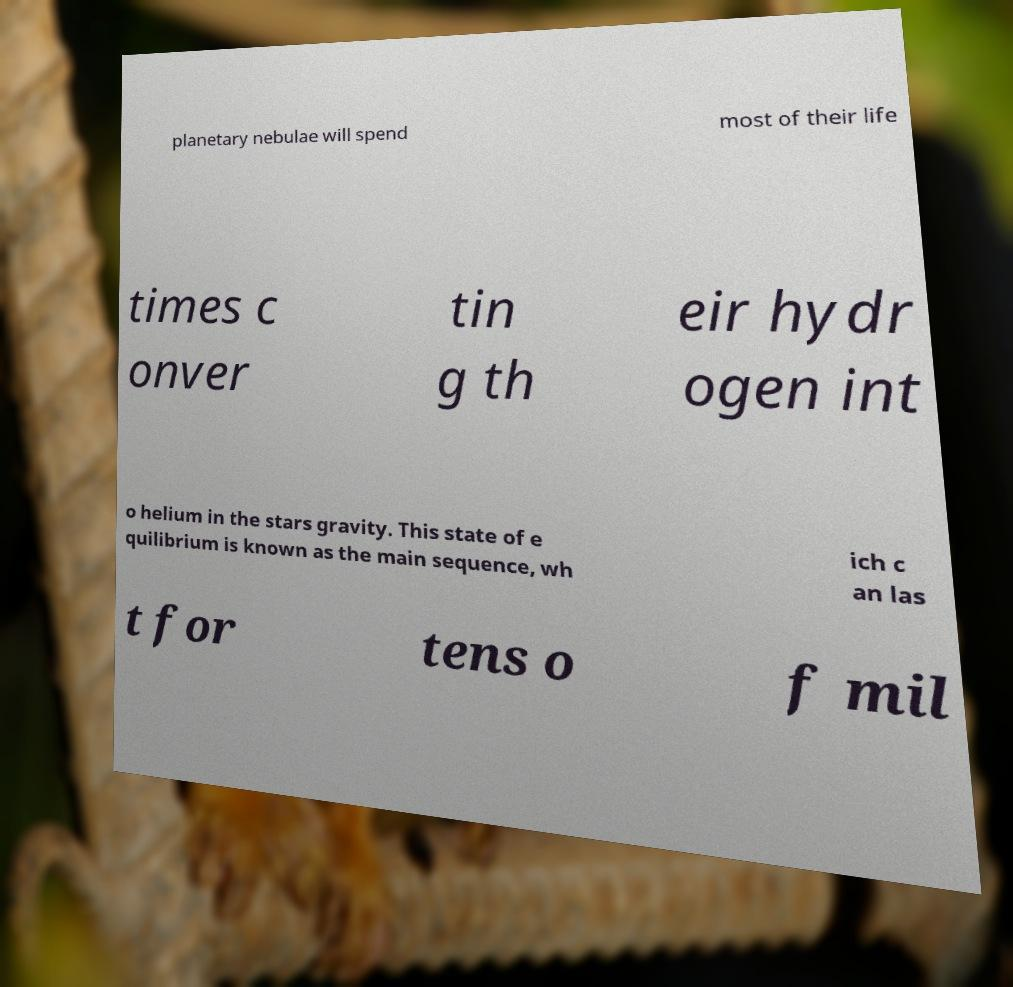Please read and relay the text visible in this image. What does it say? planetary nebulae will spend most of their life times c onver tin g th eir hydr ogen int o helium in the stars gravity. This state of e quilibrium is known as the main sequence, wh ich c an las t for tens o f mil 